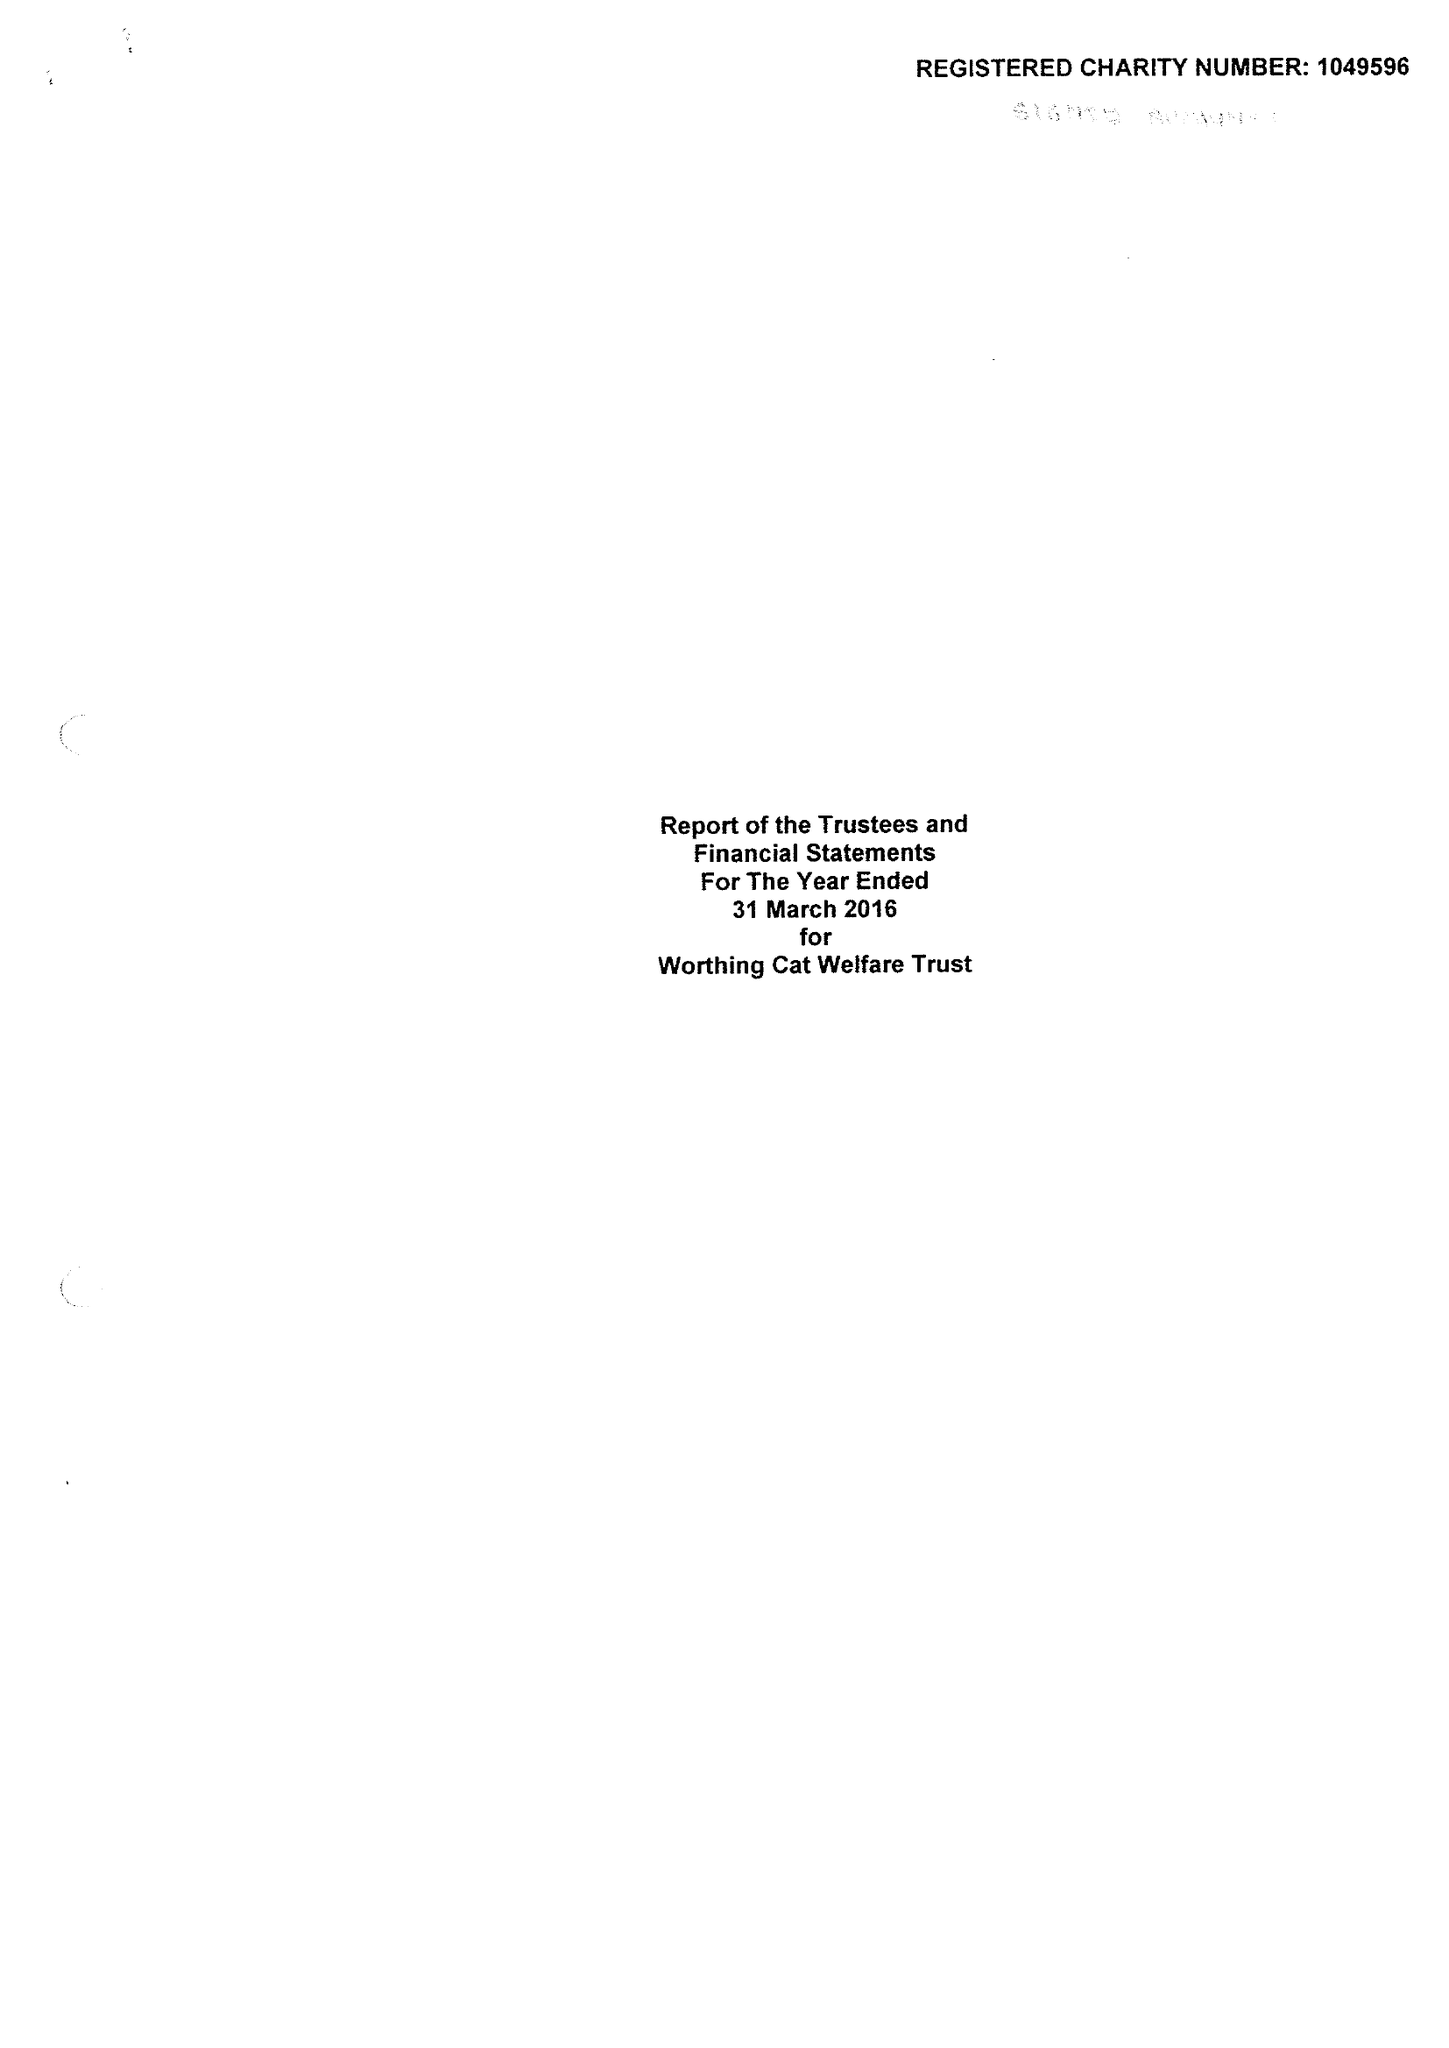What is the value for the charity_name?
Answer the question using a single word or phrase. Worthing Cat Welfare Trust 